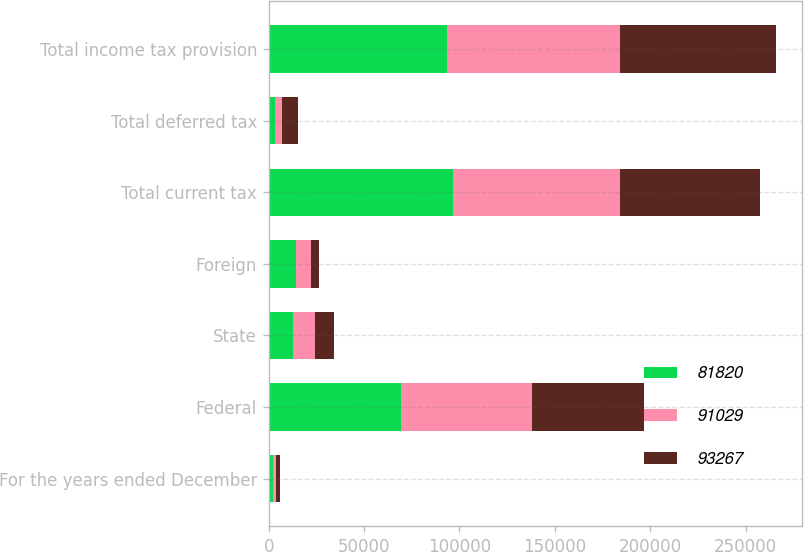Convert chart. <chart><loc_0><loc_0><loc_500><loc_500><stacked_bar_chart><ecel><fcel>For the years ended December<fcel>Federal<fcel>State<fcel>Foreign<fcel>Total current tax<fcel>Total deferred tax<fcel>Total income tax provision<nl><fcel>81820<fcel>2016<fcel>69102<fcel>12949<fcel>14464<fcel>96515<fcel>3248<fcel>93267<nl><fcel>91029<fcel>2015<fcel>68667<fcel>11335<fcel>7534<fcel>87536<fcel>3493<fcel>91029<nl><fcel>93267<fcel>2014<fcel>59053<fcel>9936<fcel>4391<fcel>73380<fcel>8440<fcel>81820<nl></chart> 